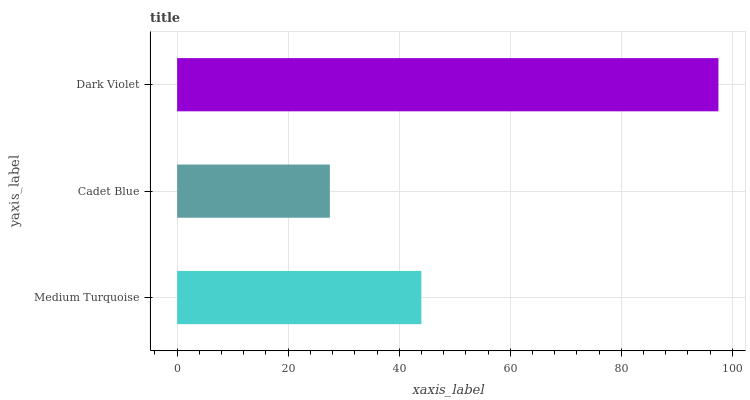Is Cadet Blue the minimum?
Answer yes or no. Yes. Is Dark Violet the maximum?
Answer yes or no. Yes. Is Dark Violet the minimum?
Answer yes or no. No. Is Cadet Blue the maximum?
Answer yes or no. No. Is Dark Violet greater than Cadet Blue?
Answer yes or no. Yes. Is Cadet Blue less than Dark Violet?
Answer yes or no. Yes. Is Cadet Blue greater than Dark Violet?
Answer yes or no. No. Is Dark Violet less than Cadet Blue?
Answer yes or no. No. Is Medium Turquoise the high median?
Answer yes or no. Yes. Is Medium Turquoise the low median?
Answer yes or no. Yes. Is Cadet Blue the high median?
Answer yes or no. No. Is Dark Violet the low median?
Answer yes or no. No. 